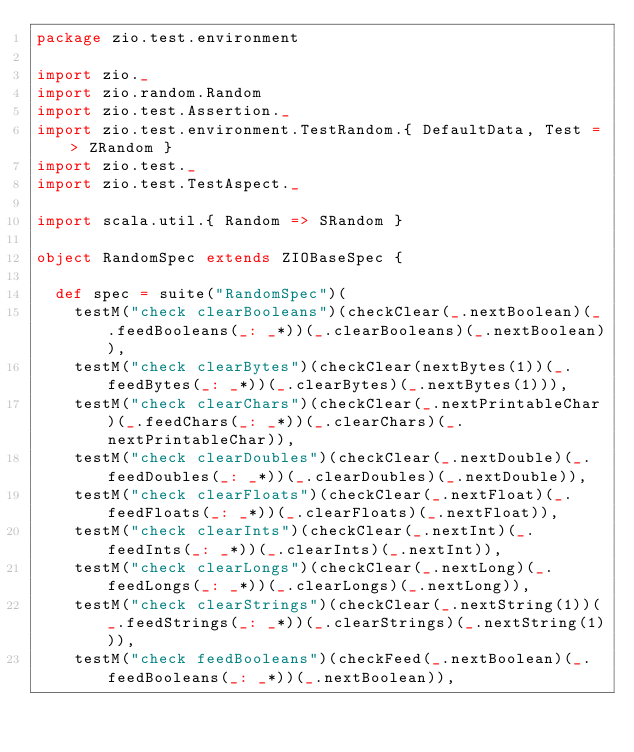<code> <loc_0><loc_0><loc_500><loc_500><_Scala_>package zio.test.environment

import zio._
import zio.random.Random
import zio.test.Assertion._
import zio.test.environment.TestRandom.{ DefaultData, Test => ZRandom }
import zio.test._
import zio.test.TestAspect._

import scala.util.{ Random => SRandom }

object RandomSpec extends ZIOBaseSpec {

  def spec = suite("RandomSpec")(
    testM("check clearBooleans")(checkClear(_.nextBoolean)(_.feedBooleans(_: _*))(_.clearBooleans)(_.nextBoolean)),
    testM("check clearBytes")(checkClear(nextBytes(1))(_.feedBytes(_: _*))(_.clearBytes)(_.nextBytes(1))),
    testM("check clearChars")(checkClear(_.nextPrintableChar)(_.feedChars(_: _*))(_.clearChars)(_.nextPrintableChar)),
    testM("check clearDoubles")(checkClear(_.nextDouble)(_.feedDoubles(_: _*))(_.clearDoubles)(_.nextDouble)),
    testM("check clearFloats")(checkClear(_.nextFloat)(_.feedFloats(_: _*))(_.clearFloats)(_.nextFloat)),
    testM("check clearInts")(checkClear(_.nextInt)(_.feedInts(_: _*))(_.clearInts)(_.nextInt)),
    testM("check clearLongs")(checkClear(_.nextLong)(_.feedLongs(_: _*))(_.clearLongs)(_.nextLong)),
    testM("check clearStrings")(checkClear(_.nextString(1))(_.feedStrings(_: _*))(_.clearStrings)(_.nextString(1))),
    testM("check feedBooleans")(checkFeed(_.nextBoolean)(_.feedBooleans(_: _*))(_.nextBoolean)),</code> 